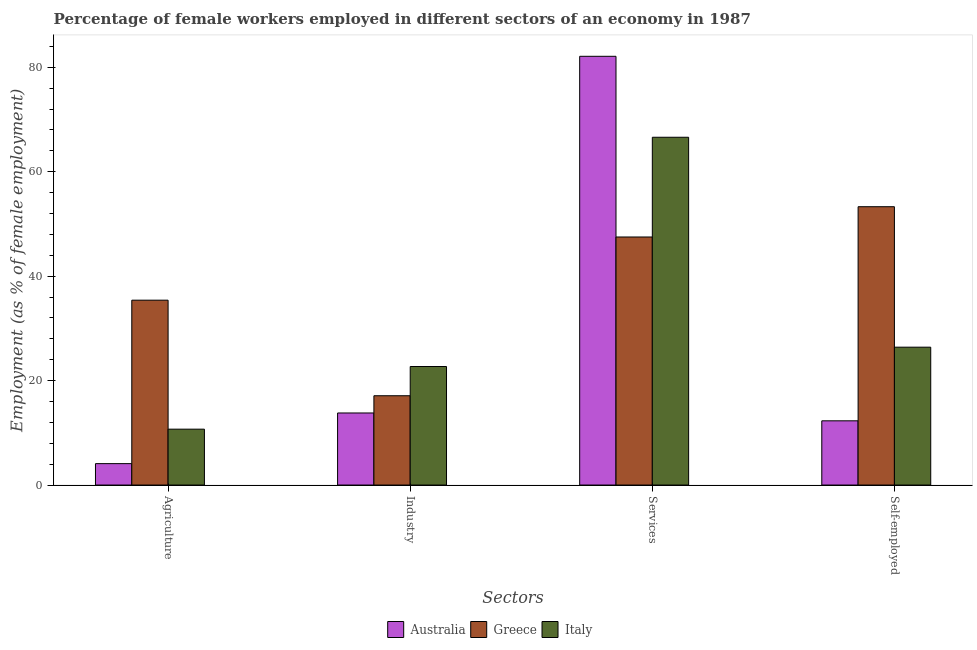How many different coloured bars are there?
Make the answer very short. 3. Are the number of bars on each tick of the X-axis equal?
Offer a very short reply. Yes. How many bars are there on the 1st tick from the left?
Make the answer very short. 3. What is the label of the 2nd group of bars from the left?
Provide a short and direct response. Industry. What is the percentage of female workers in services in Australia?
Offer a very short reply. 82.1. Across all countries, what is the maximum percentage of female workers in services?
Provide a succinct answer. 82.1. Across all countries, what is the minimum percentage of self employed female workers?
Offer a terse response. 12.3. In which country was the percentage of female workers in services maximum?
Your answer should be compact. Australia. In which country was the percentage of female workers in services minimum?
Give a very brief answer. Greece. What is the total percentage of self employed female workers in the graph?
Provide a short and direct response. 92. What is the difference between the percentage of self employed female workers in Italy and that in Australia?
Ensure brevity in your answer.  14.1. What is the difference between the percentage of female workers in agriculture in Australia and the percentage of self employed female workers in Italy?
Ensure brevity in your answer.  -22.3. What is the average percentage of female workers in agriculture per country?
Provide a succinct answer. 16.73. What is the difference between the percentage of female workers in industry and percentage of self employed female workers in Italy?
Your response must be concise. -3.7. What is the ratio of the percentage of female workers in industry in Greece to that in Italy?
Offer a very short reply. 0.75. What is the difference between the highest and the second highest percentage of female workers in services?
Offer a terse response. 15.5. What is the difference between the highest and the lowest percentage of female workers in agriculture?
Give a very brief answer. 31.3. What does the 3rd bar from the right in Self-employed represents?
Provide a short and direct response. Australia. Is it the case that in every country, the sum of the percentage of female workers in agriculture and percentage of female workers in industry is greater than the percentage of female workers in services?
Give a very brief answer. No. How many countries are there in the graph?
Keep it short and to the point. 3. What is the difference between two consecutive major ticks on the Y-axis?
Ensure brevity in your answer.  20. Does the graph contain any zero values?
Give a very brief answer. No. Does the graph contain grids?
Give a very brief answer. No. What is the title of the graph?
Offer a terse response. Percentage of female workers employed in different sectors of an economy in 1987. What is the label or title of the X-axis?
Keep it short and to the point. Sectors. What is the label or title of the Y-axis?
Make the answer very short. Employment (as % of female employment). What is the Employment (as % of female employment) of Australia in Agriculture?
Ensure brevity in your answer.  4.1. What is the Employment (as % of female employment) of Greece in Agriculture?
Your response must be concise. 35.4. What is the Employment (as % of female employment) in Italy in Agriculture?
Give a very brief answer. 10.7. What is the Employment (as % of female employment) of Australia in Industry?
Give a very brief answer. 13.8. What is the Employment (as % of female employment) of Greece in Industry?
Your response must be concise. 17.1. What is the Employment (as % of female employment) in Italy in Industry?
Keep it short and to the point. 22.7. What is the Employment (as % of female employment) of Australia in Services?
Offer a terse response. 82.1. What is the Employment (as % of female employment) in Greece in Services?
Give a very brief answer. 47.5. What is the Employment (as % of female employment) in Italy in Services?
Offer a very short reply. 66.6. What is the Employment (as % of female employment) of Australia in Self-employed?
Your answer should be very brief. 12.3. What is the Employment (as % of female employment) in Greece in Self-employed?
Your answer should be very brief. 53.3. What is the Employment (as % of female employment) in Italy in Self-employed?
Your answer should be compact. 26.4. Across all Sectors, what is the maximum Employment (as % of female employment) of Australia?
Your answer should be compact. 82.1. Across all Sectors, what is the maximum Employment (as % of female employment) of Greece?
Make the answer very short. 53.3. Across all Sectors, what is the maximum Employment (as % of female employment) of Italy?
Your answer should be very brief. 66.6. Across all Sectors, what is the minimum Employment (as % of female employment) of Australia?
Ensure brevity in your answer.  4.1. Across all Sectors, what is the minimum Employment (as % of female employment) of Greece?
Ensure brevity in your answer.  17.1. Across all Sectors, what is the minimum Employment (as % of female employment) in Italy?
Your answer should be compact. 10.7. What is the total Employment (as % of female employment) in Australia in the graph?
Your answer should be very brief. 112.3. What is the total Employment (as % of female employment) of Greece in the graph?
Provide a short and direct response. 153.3. What is the total Employment (as % of female employment) of Italy in the graph?
Your answer should be very brief. 126.4. What is the difference between the Employment (as % of female employment) in Australia in Agriculture and that in Industry?
Ensure brevity in your answer.  -9.7. What is the difference between the Employment (as % of female employment) of Australia in Agriculture and that in Services?
Make the answer very short. -78. What is the difference between the Employment (as % of female employment) of Italy in Agriculture and that in Services?
Offer a very short reply. -55.9. What is the difference between the Employment (as % of female employment) in Australia in Agriculture and that in Self-employed?
Give a very brief answer. -8.2. What is the difference between the Employment (as % of female employment) of Greece in Agriculture and that in Self-employed?
Your response must be concise. -17.9. What is the difference between the Employment (as % of female employment) of Italy in Agriculture and that in Self-employed?
Ensure brevity in your answer.  -15.7. What is the difference between the Employment (as % of female employment) in Australia in Industry and that in Services?
Give a very brief answer. -68.3. What is the difference between the Employment (as % of female employment) in Greece in Industry and that in Services?
Provide a short and direct response. -30.4. What is the difference between the Employment (as % of female employment) in Italy in Industry and that in Services?
Keep it short and to the point. -43.9. What is the difference between the Employment (as % of female employment) of Australia in Industry and that in Self-employed?
Your response must be concise. 1.5. What is the difference between the Employment (as % of female employment) of Greece in Industry and that in Self-employed?
Offer a terse response. -36.2. What is the difference between the Employment (as % of female employment) in Australia in Services and that in Self-employed?
Your response must be concise. 69.8. What is the difference between the Employment (as % of female employment) of Greece in Services and that in Self-employed?
Your answer should be very brief. -5.8. What is the difference between the Employment (as % of female employment) in Italy in Services and that in Self-employed?
Ensure brevity in your answer.  40.2. What is the difference between the Employment (as % of female employment) in Australia in Agriculture and the Employment (as % of female employment) in Italy in Industry?
Make the answer very short. -18.6. What is the difference between the Employment (as % of female employment) of Australia in Agriculture and the Employment (as % of female employment) of Greece in Services?
Give a very brief answer. -43.4. What is the difference between the Employment (as % of female employment) in Australia in Agriculture and the Employment (as % of female employment) in Italy in Services?
Your answer should be compact. -62.5. What is the difference between the Employment (as % of female employment) of Greece in Agriculture and the Employment (as % of female employment) of Italy in Services?
Provide a short and direct response. -31.2. What is the difference between the Employment (as % of female employment) in Australia in Agriculture and the Employment (as % of female employment) in Greece in Self-employed?
Provide a succinct answer. -49.2. What is the difference between the Employment (as % of female employment) of Australia in Agriculture and the Employment (as % of female employment) of Italy in Self-employed?
Make the answer very short. -22.3. What is the difference between the Employment (as % of female employment) in Greece in Agriculture and the Employment (as % of female employment) in Italy in Self-employed?
Your answer should be very brief. 9. What is the difference between the Employment (as % of female employment) in Australia in Industry and the Employment (as % of female employment) in Greece in Services?
Offer a very short reply. -33.7. What is the difference between the Employment (as % of female employment) in Australia in Industry and the Employment (as % of female employment) in Italy in Services?
Offer a terse response. -52.8. What is the difference between the Employment (as % of female employment) in Greece in Industry and the Employment (as % of female employment) in Italy in Services?
Make the answer very short. -49.5. What is the difference between the Employment (as % of female employment) of Australia in Industry and the Employment (as % of female employment) of Greece in Self-employed?
Give a very brief answer. -39.5. What is the difference between the Employment (as % of female employment) in Greece in Industry and the Employment (as % of female employment) in Italy in Self-employed?
Provide a short and direct response. -9.3. What is the difference between the Employment (as % of female employment) of Australia in Services and the Employment (as % of female employment) of Greece in Self-employed?
Make the answer very short. 28.8. What is the difference between the Employment (as % of female employment) in Australia in Services and the Employment (as % of female employment) in Italy in Self-employed?
Offer a terse response. 55.7. What is the difference between the Employment (as % of female employment) in Greece in Services and the Employment (as % of female employment) in Italy in Self-employed?
Your answer should be compact. 21.1. What is the average Employment (as % of female employment) of Australia per Sectors?
Make the answer very short. 28.07. What is the average Employment (as % of female employment) in Greece per Sectors?
Offer a terse response. 38.33. What is the average Employment (as % of female employment) of Italy per Sectors?
Give a very brief answer. 31.6. What is the difference between the Employment (as % of female employment) in Australia and Employment (as % of female employment) in Greece in Agriculture?
Provide a succinct answer. -31.3. What is the difference between the Employment (as % of female employment) of Australia and Employment (as % of female employment) of Italy in Agriculture?
Offer a very short reply. -6.6. What is the difference between the Employment (as % of female employment) in Greece and Employment (as % of female employment) in Italy in Agriculture?
Provide a short and direct response. 24.7. What is the difference between the Employment (as % of female employment) of Australia and Employment (as % of female employment) of Greece in Industry?
Make the answer very short. -3.3. What is the difference between the Employment (as % of female employment) of Greece and Employment (as % of female employment) of Italy in Industry?
Offer a terse response. -5.6. What is the difference between the Employment (as % of female employment) of Australia and Employment (as % of female employment) of Greece in Services?
Provide a succinct answer. 34.6. What is the difference between the Employment (as % of female employment) in Australia and Employment (as % of female employment) in Italy in Services?
Make the answer very short. 15.5. What is the difference between the Employment (as % of female employment) in Greece and Employment (as % of female employment) in Italy in Services?
Your response must be concise. -19.1. What is the difference between the Employment (as % of female employment) in Australia and Employment (as % of female employment) in Greece in Self-employed?
Make the answer very short. -41. What is the difference between the Employment (as % of female employment) of Australia and Employment (as % of female employment) of Italy in Self-employed?
Keep it short and to the point. -14.1. What is the difference between the Employment (as % of female employment) in Greece and Employment (as % of female employment) in Italy in Self-employed?
Give a very brief answer. 26.9. What is the ratio of the Employment (as % of female employment) in Australia in Agriculture to that in Industry?
Provide a short and direct response. 0.3. What is the ratio of the Employment (as % of female employment) in Greece in Agriculture to that in Industry?
Your response must be concise. 2.07. What is the ratio of the Employment (as % of female employment) in Italy in Agriculture to that in Industry?
Offer a very short reply. 0.47. What is the ratio of the Employment (as % of female employment) of Australia in Agriculture to that in Services?
Make the answer very short. 0.05. What is the ratio of the Employment (as % of female employment) in Greece in Agriculture to that in Services?
Provide a succinct answer. 0.75. What is the ratio of the Employment (as % of female employment) in Italy in Agriculture to that in Services?
Your answer should be compact. 0.16. What is the ratio of the Employment (as % of female employment) in Greece in Agriculture to that in Self-employed?
Keep it short and to the point. 0.66. What is the ratio of the Employment (as % of female employment) in Italy in Agriculture to that in Self-employed?
Your answer should be very brief. 0.41. What is the ratio of the Employment (as % of female employment) in Australia in Industry to that in Services?
Offer a terse response. 0.17. What is the ratio of the Employment (as % of female employment) of Greece in Industry to that in Services?
Your response must be concise. 0.36. What is the ratio of the Employment (as % of female employment) in Italy in Industry to that in Services?
Ensure brevity in your answer.  0.34. What is the ratio of the Employment (as % of female employment) in Australia in Industry to that in Self-employed?
Make the answer very short. 1.12. What is the ratio of the Employment (as % of female employment) in Greece in Industry to that in Self-employed?
Provide a short and direct response. 0.32. What is the ratio of the Employment (as % of female employment) in Italy in Industry to that in Self-employed?
Make the answer very short. 0.86. What is the ratio of the Employment (as % of female employment) of Australia in Services to that in Self-employed?
Offer a terse response. 6.67. What is the ratio of the Employment (as % of female employment) in Greece in Services to that in Self-employed?
Ensure brevity in your answer.  0.89. What is the ratio of the Employment (as % of female employment) of Italy in Services to that in Self-employed?
Make the answer very short. 2.52. What is the difference between the highest and the second highest Employment (as % of female employment) in Australia?
Offer a very short reply. 68.3. What is the difference between the highest and the second highest Employment (as % of female employment) in Greece?
Make the answer very short. 5.8. What is the difference between the highest and the second highest Employment (as % of female employment) of Italy?
Provide a short and direct response. 40.2. What is the difference between the highest and the lowest Employment (as % of female employment) in Australia?
Provide a short and direct response. 78. What is the difference between the highest and the lowest Employment (as % of female employment) of Greece?
Your answer should be compact. 36.2. What is the difference between the highest and the lowest Employment (as % of female employment) in Italy?
Give a very brief answer. 55.9. 